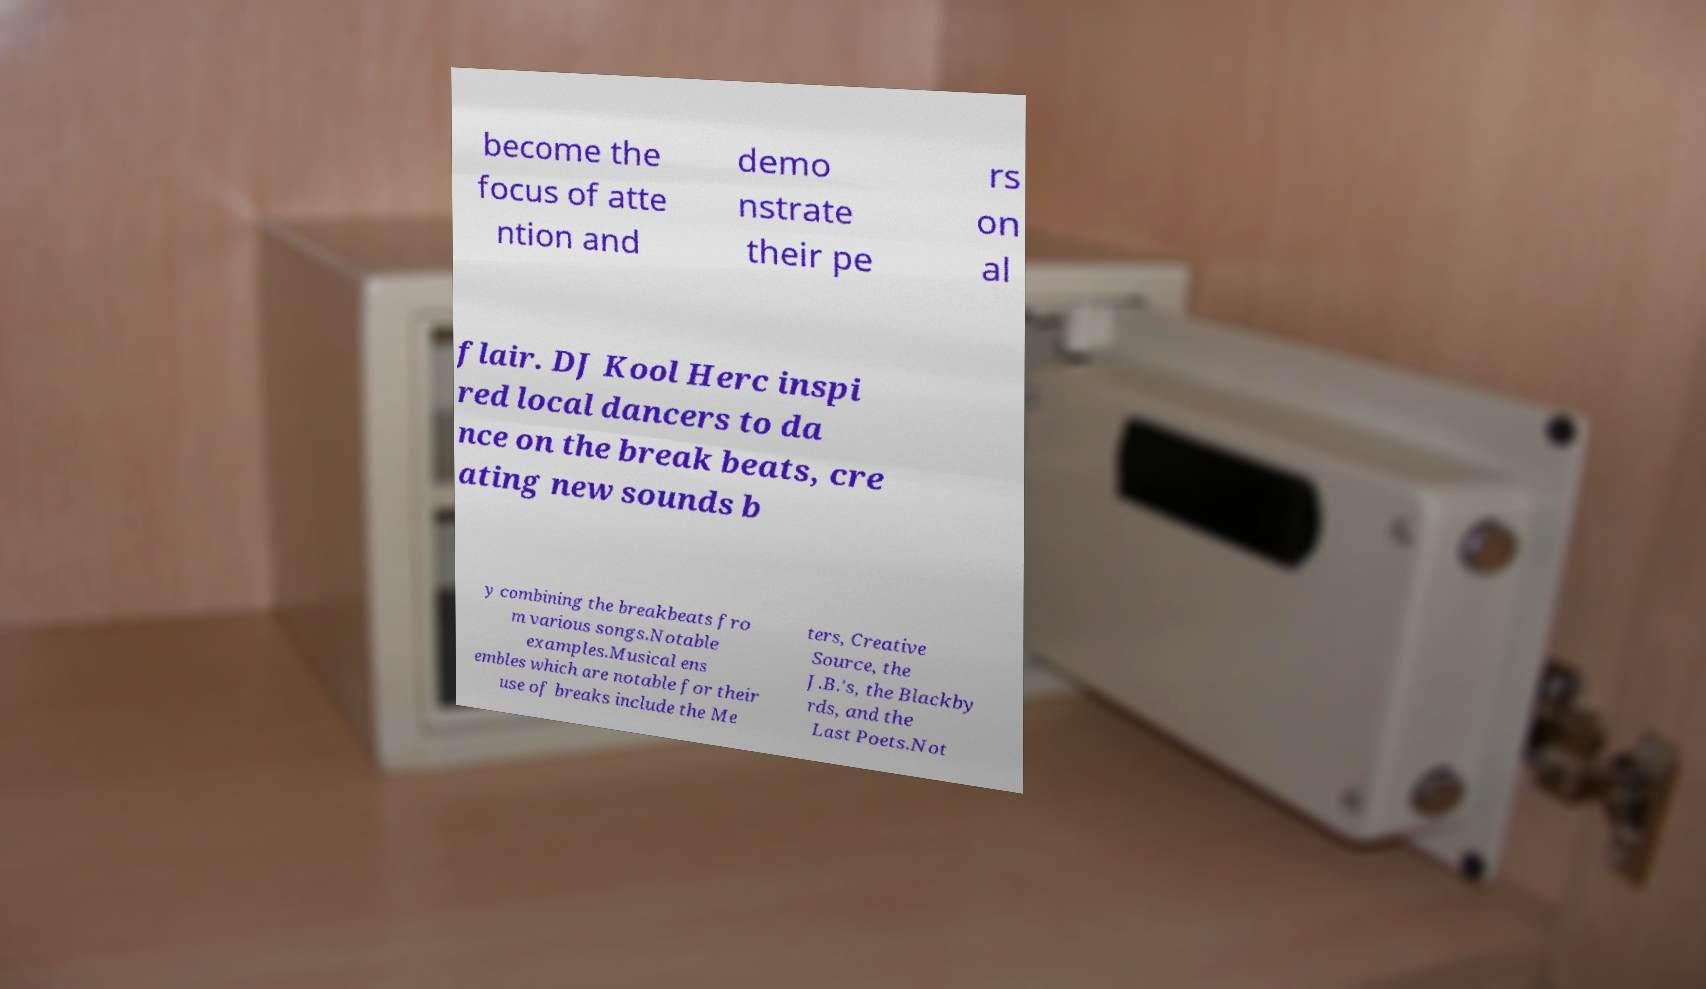Could you extract and type out the text from this image? become the focus of atte ntion and demo nstrate their pe rs on al flair. DJ Kool Herc inspi red local dancers to da nce on the break beats, cre ating new sounds b y combining the breakbeats fro m various songs.Notable examples.Musical ens embles which are notable for their use of breaks include the Me ters, Creative Source, the J.B.'s, the Blackby rds, and the Last Poets.Not 